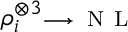Convert formula to latex. <formula><loc_0><loc_0><loc_500><loc_500>\rho _ { i } ^ { \otimes 3 } \substack { \longrightarrow \, N L }</formula> 